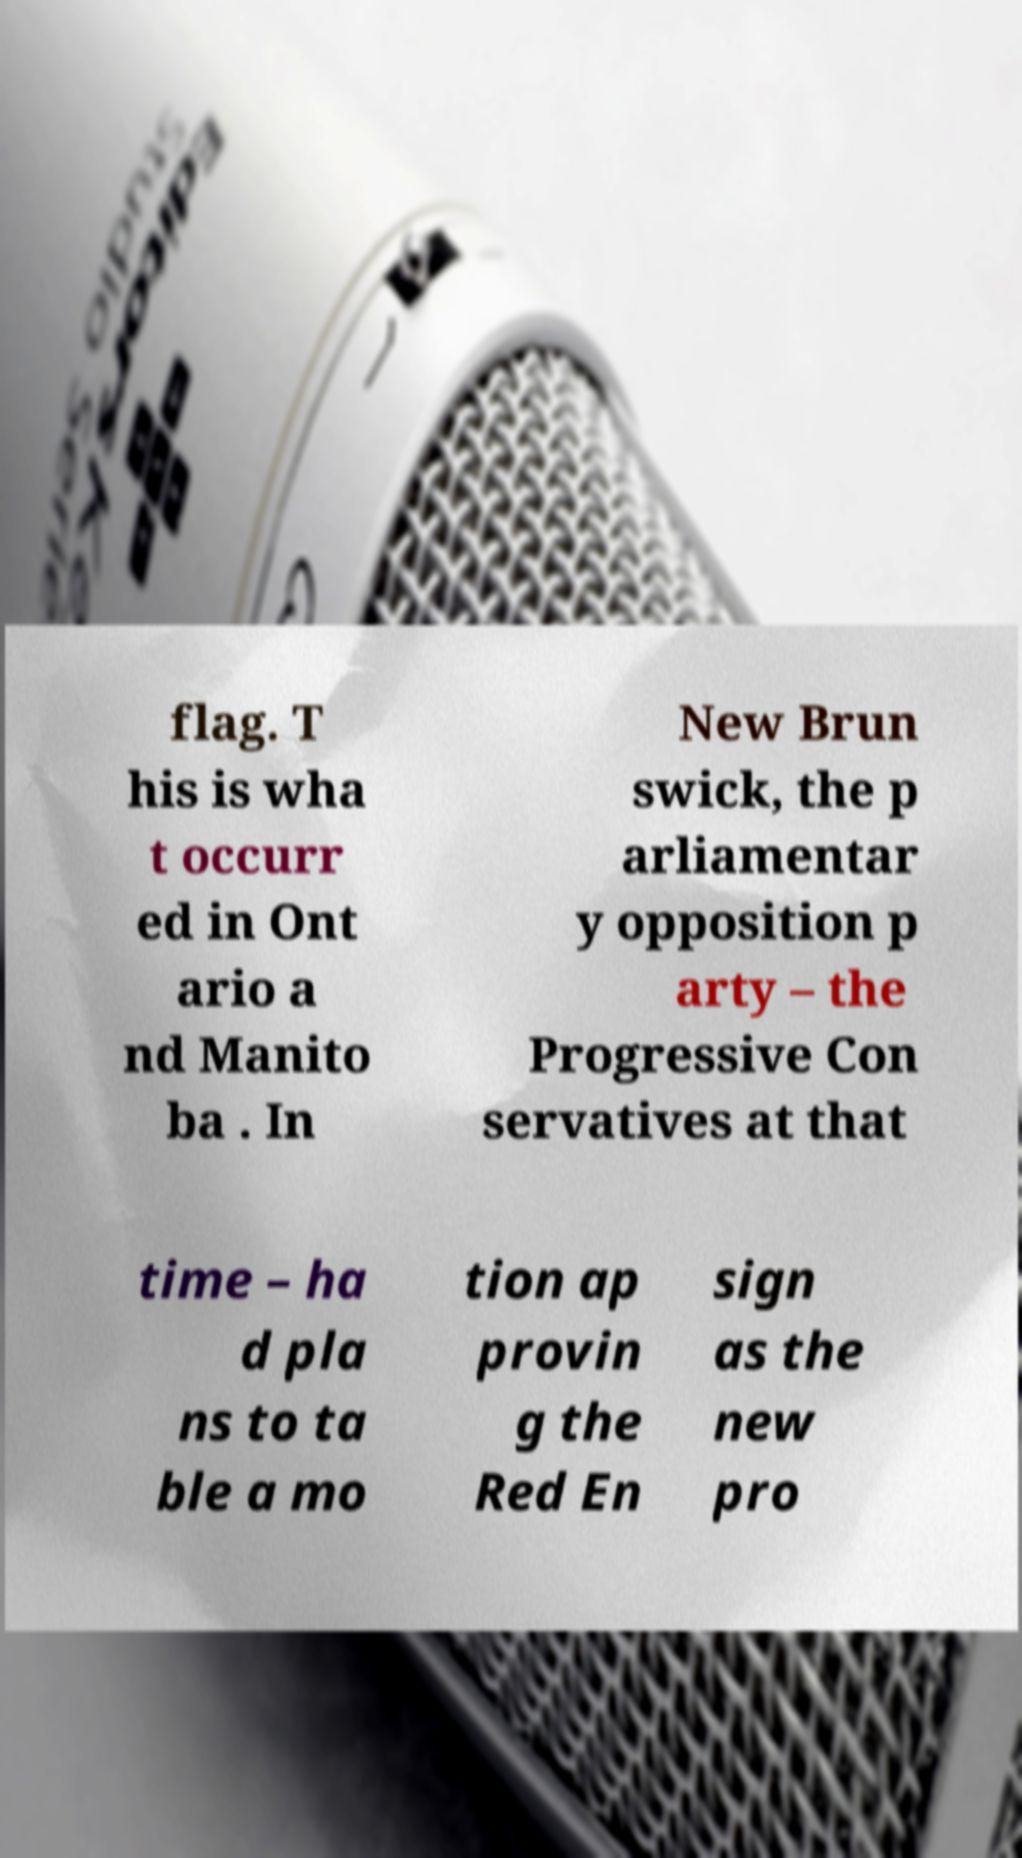Could you extract and type out the text from this image? flag. T his is wha t occurr ed in Ont ario a nd Manito ba . In New Brun swick, the p arliamentar y opposition p arty – the Progressive Con servatives at that time – ha d pla ns to ta ble a mo tion ap provin g the Red En sign as the new pro 